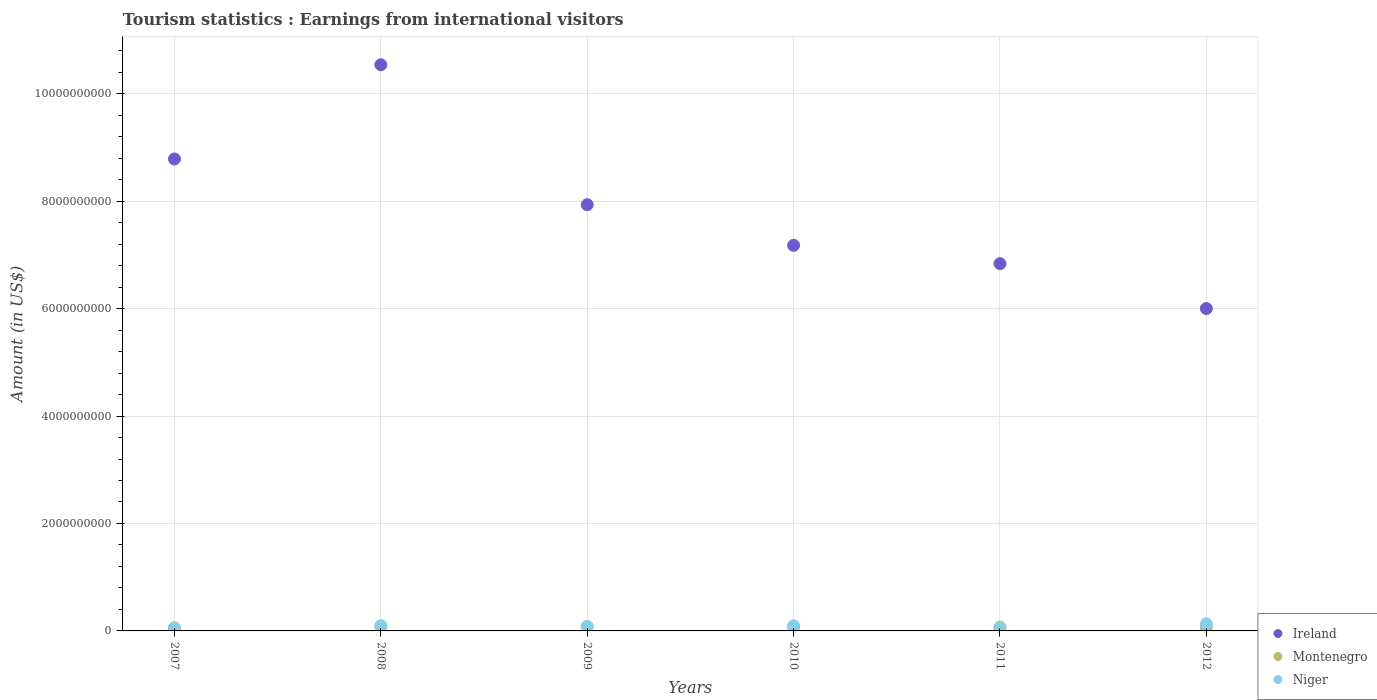What is the earnings from international visitors in Montenegro in 2007?
Your answer should be compact. 5.80e+07. Across all years, what is the maximum earnings from international visitors in Niger?
Provide a succinct answer. 1.32e+08. Across all years, what is the minimum earnings from international visitors in Ireland?
Your answer should be very brief. 6.00e+09. What is the total earnings from international visitors in Niger in the graph?
Provide a short and direct response. 5.14e+08. What is the difference between the earnings from international visitors in Niger in 2007 and that in 2009?
Your answer should be very brief. -3.60e+07. What is the difference between the earnings from international visitors in Niger in 2011 and the earnings from international visitors in Ireland in 2010?
Ensure brevity in your answer.  -7.12e+09. What is the average earnings from international visitors in Niger per year?
Keep it short and to the point. 8.57e+07. In the year 2007, what is the difference between the earnings from international visitors in Ireland and earnings from international visitors in Niger?
Provide a short and direct response. 8.74e+09. What is the ratio of the earnings from international visitors in Ireland in 2008 to that in 2010?
Give a very brief answer. 1.47. Is the earnings from international visitors in Ireland in 2008 less than that in 2011?
Provide a short and direct response. No. Is the difference between the earnings from international visitors in Ireland in 2007 and 2008 greater than the difference between the earnings from international visitors in Niger in 2007 and 2008?
Your answer should be very brief. No. What is the difference between the highest and the second highest earnings from international visitors in Ireland?
Make the answer very short. 1.75e+09. What is the difference between the highest and the lowest earnings from international visitors in Ireland?
Provide a succinct answer. 4.54e+09. Is the sum of the earnings from international visitors in Niger in 2010 and 2012 greater than the maximum earnings from international visitors in Montenegro across all years?
Provide a succinct answer. Yes. How many dotlines are there?
Provide a succinct answer. 3. How many years are there in the graph?
Your answer should be very brief. 6. What is the difference between two consecutive major ticks on the Y-axis?
Your response must be concise. 2.00e+09. Are the values on the major ticks of Y-axis written in scientific E-notation?
Ensure brevity in your answer.  No. How are the legend labels stacked?
Keep it short and to the point. Vertical. What is the title of the graph?
Keep it short and to the point. Tourism statistics : Earnings from international visitors. What is the label or title of the X-axis?
Your response must be concise. Years. What is the label or title of the Y-axis?
Your answer should be compact. Amount (in US$). What is the Amount (in US$) of Ireland in 2007?
Keep it short and to the point. 8.78e+09. What is the Amount (in US$) of Montenegro in 2007?
Your response must be concise. 5.80e+07. What is the Amount (in US$) of Niger in 2007?
Keep it short and to the point. 4.80e+07. What is the Amount (in US$) of Ireland in 2008?
Give a very brief answer. 1.05e+1. What is the Amount (in US$) of Montenegro in 2008?
Offer a terse response. 8.00e+07. What is the Amount (in US$) of Niger in 2008?
Offer a very short reply. 9.80e+07. What is the Amount (in US$) of Ireland in 2009?
Offer a very short reply. 7.93e+09. What is the Amount (in US$) of Montenegro in 2009?
Ensure brevity in your answer.  7.60e+07. What is the Amount (in US$) of Niger in 2009?
Give a very brief answer. 8.40e+07. What is the Amount (in US$) in Ireland in 2010?
Offer a terse response. 7.18e+09. What is the Amount (in US$) of Montenegro in 2010?
Provide a succinct answer. 7.20e+07. What is the Amount (in US$) of Niger in 2010?
Provide a succinct answer. 9.50e+07. What is the Amount (in US$) in Ireland in 2011?
Provide a short and direct response. 6.84e+09. What is the Amount (in US$) in Montenegro in 2011?
Make the answer very short. 7.00e+07. What is the Amount (in US$) in Niger in 2011?
Ensure brevity in your answer.  5.70e+07. What is the Amount (in US$) of Ireland in 2012?
Give a very brief answer. 6.00e+09. What is the Amount (in US$) of Montenegro in 2012?
Your answer should be compact. 6.70e+07. What is the Amount (in US$) in Niger in 2012?
Your response must be concise. 1.32e+08. Across all years, what is the maximum Amount (in US$) of Ireland?
Offer a very short reply. 1.05e+1. Across all years, what is the maximum Amount (in US$) in Montenegro?
Keep it short and to the point. 8.00e+07. Across all years, what is the maximum Amount (in US$) of Niger?
Your response must be concise. 1.32e+08. Across all years, what is the minimum Amount (in US$) of Ireland?
Your answer should be very brief. 6.00e+09. Across all years, what is the minimum Amount (in US$) in Montenegro?
Your answer should be compact. 5.80e+07. Across all years, what is the minimum Amount (in US$) in Niger?
Offer a very short reply. 4.80e+07. What is the total Amount (in US$) of Ireland in the graph?
Your answer should be very brief. 4.73e+1. What is the total Amount (in US$) in Montenegro in the graph?
Provide a short and direct response. 4.23e+08. What is the total Amount (in US$) of Niger in the graph?
Your answer should be compact. 5.14e+08. What is the difference between the Amount (in US$) in Ireland in 2007 and that in 2008?
Offer a terse response. -1.75e+09. What is the difference between the Amount (in US$) in Montenegro in 2007 and that in 2008?
Give a very brief answer. -2.20e+07. What is the difference between the Amount (in US$) of Niger in 2007 and that in 2008?
Keep it short and to the point. -5.00e+07. What is the difference between the Amount (in US$) of Ireland in 2007 and that in 2009?
Give a very brief answer. 8.51e+08. What is the difference between the Amount (in US$) in Montenegro in 2007 and that in 2009?
Offer a terse response. -1.80e+07. What is the difference between the Amount (in US$) in Niger in 2007 and that in 2009?
Keep it short and to the point. -3.60e+07. What is the difference between the Amount (in US$) of Ireland in 2007 and that in 2010?
Your answer should be compact. 1.61e+09. What is the difference between the Amount (in US$) in Montenegro in 2007 and that in 2010?
Provide a short and direct response. -1.40e+07. What is the difference between the Amount (in US$) of Niger in 2007 and that in 2010?
Make the answer very short. -4.70e+07. What is the difference between the Amount (in US$) of Ireland in 2007 and that in 2011?
Provide a succinct answer. 1.95e+09. What is the difference between the Amount (in US$) of Montenegro in 2007 and that in 2011?
Provide a short and direct response. -1.20e+07. What is the difference between the Amount (in US$) of Niger in 2007 and that in 2011?
Keep it short and to the point. -9.00e+06. What is the difference between the Amount (in US$) of Ireland in 2007 and that in 2012?
Provide a short and direct response. 2.78e+09. What is the difference between the Amount (in US$) in Montenegro in 2007 and that in 2012?
Your answer should be very brief. -9.00e+06. What is the difference between the Amount (in US$) in Niger in 2007 and that in 2012?
Make the answer very short. -8.40e+07. What is the difference between the Amount (in US$) of Ireland in 2008 and that in 2009?
Give a very brief answer. 2.60e+09. What is the difference between the Amount (in US$) of Montenegro in 2008 and that in 2009?
Your response must be concise. 4.00e+06. What is the difference between the Amount (in US$) of Niger in 2008 and that in 2009?
Keep it short and to the point. 1.40e+07. What is the difference between the Amount (in US$) of Ireland in 2008 and that in 2010?
Provide a short and direct response. 3.36e+09. What is the difference between the Amount (in US$) in Niger in 2008 and that in 2010?
Offer a very short reply. 3.00e+06. What is the difference between the Amount (in US$) in Ireland in 2008 and that in 2011?
Your answer should be compact. 3.70e+09. What is the difference between the Amount (in US$) of Niger in 2008 and that in 2011?
Your response must be concise. 4.10e+07. What is the difference between the Amount (in US$) in Ireland in 2008 and that in 2012?
Your answer should be very brief. 4.54e+09. What is the difference between the Amount (in US$) of Montenegro in 2008 and that in 2012?
Ensure brevity in your answer.  1.30e+07. What is the difference between the Amount (in US$) in Niger in 2008 and that in 2012?
Offer a very short reply. -3.40e+07. What is the difference between the Amount (in US$) of Ireland in 2009 and that in 2010?
Your answer should be compact. 7.56e+08. What is the difference between the Amount (in US$) in Niger in 2009 and that in 2010?
Provide a short and direct response. -1.10e+07. What is the difference between the Amount (in US$) in Ireland in 2009 and that in 2011?
Your answer should be compact. 1.10e+09. What is the difference between the Amount (in US$) in Niger in 2009 and that in 2011?
Provide a succinct answer. 2.70e+07. What is the difference between the Amount (in US$) in Ireland in 2009 and that in 2012?
Offer a very short reply. 1.93e+09. What is the difference between the Amount (in US$) of Montenegro in 2009 and that in 2012?
Your response must be concise. 9.00e+06. What is the difference between the Amount (in US$) in Niger in 2009 and that in 2012?
Provide a short and direct response. -4.80e+07. What is the difference between the Amount (in US$) of Ireland in 2010 and that in 2011?
Offer a very short reply. 3.41e+08. What is the difference between the Amount (in US$) in Montenegro in 2010 and that in 2011?
Your answer should be compact. 2.00e+06. What is the difference between the Amount (in US$) of Niger in 2010 and that in 2011?
Your answer should be compact. 3.80e+07. What is the difference between the Amount (in US$) of Ireland in 2010 and that in 2012?
Provide a short and direct response. 1.18e+09. What is the difference between the Amount (in US$) in Montenegro in 2010 and that in 2012?
Your answer should be compact. 5.00e+06. What is the difference between the Amount (in US$) in Niger in 2010 and that in 2012?
Your response must be concise. -3.70e+07. What is the difference between the Amount (in US$) in Ireland in 2011 and that in 2012?
Provide a short and direct response. 8.36e+08. What is the difference between the Amount (in US$) in Montenegro in 2011 and that in 2012?
Ensure brevity in your answer.  3.00e+06. What is the difference between the Amount (in US$) in Niger in 2011 and that in 2012?
Your answer should be compact. -7.50e+07. What is the difference between the Amount (in US$) in Ireland in 2007 and the Amount (in US$) in Montenegro in 2008?
Your answer should be compact. 8.70e+09. What is the difference between the Amount (in US$) in Ireland in 2007 and the Amount (in US$) in Niger in 2008?
Keep it short and to the point. 8.69e+09. What is the difference between the Amount (in US$) of Montenegro in 2007 and the Amount (in US$) of Niger in 2008?
Your answer should be compact. -4.00e+07. What is the difference between the Amount (in US$) of Ireland in 2007 and the Amount (in US$) of Montenegro in 2009?
Your response must be concise. 8.71e+09. What is the difference between the Amount (in US$) in Ireland in 2007 and the Amount (in US$) in Niger in 2009?
Your answer should be very brief. 8.70e+09. What is the difference between the Amount (in US$) of Montenegro in 2007 and the Amount (in US$) of Niger in 2009?
Make the answer very short. -2.60e+07. What is the difference between the Amount (in US$) of Ireland in 2007 and the Amount (in US$) of Montenegro in 2010?
Your answer should be compact. 8.71e+09. What is the difference between the Amount (in US$) in Ireland in 2007 and the Amount (in US$) in Niger in 2010?
Your answer should be compact. 8.69e+09. What is the difference between the Amount (in US$) of Montenegro in 2007 and the Amount (in US$) of Niger in 2010?
Offer a terse response. -3.70e+07. What is the difference between the Amount (in US$) in Ireland in 2007 and the Amount (in US$) in Montenegro in 2011?
Offer a terse response. 8.72e+09. What is the difference between the Amount (in US$) in Ireland in 2007 and the Amount (in US$) in Niger in 2011?
Provide a short and direct response. 8.73e+09. What is the difference between the Amount (in US$) in Ireland in 2007 and the Amount (in US$) in Montenegro in 2012?
Give a very brief answer. 8.72e+09. What is the difference between the Amount (in US$) in Ireland in 2007 and the Amount (in US$) in Niger in 2012?
Your answer should be compact. 8.65e+09. What is the difference between the Amount (in US$) in Montenegro in 2007 and the Amount (in US$) in Niger in 2012?
Offer a very short reply. -7.40e+07. What is the difference between the Amount (in US$) in Ireland in 2008 and the Amount (in US$) in Montenegro in 2009?
Make the answer very short. 1.05e+1. What is the difference between the Amount (in US$) in Ireland in 2008 and the Amount (in US$) in Niger in 2009?
Make the answer very short. 1.05e+1. What is the difference between the Amount (in US$) of Ireland in 2008 and the Amount (in US$) of Montenegro in 2010?
Make the answer very short. 1.05e+1. What is the difference between the Amount (in US$) of Ireland in 2008 and the Amount (in US$) of Niger in 2010?
Ensure brevity in your answer.  1.04e+1. What is the difference between the Amount (in US$) in Montenegro in 2008 and the Amount (in US$) in Niger in 2010?
Provide a short and direct response. -1.50e+07. What is the difference between the Amount (in US$) in Ireland in 2008 and the Amount (in US$) in Montenegro in 2011?
Give a very brief answer. 1.05e+1. What is the difference between the Amount (in US$) in Ireland in 2008 and the Amount (in US$) in Niger in 2011?
Keep it short and to the point. 1.05e+1. What is the difference between the Amount (in US$) of Montenegro in 2008 and the Amount (in US$) of Niger in 2011?
Your response must be concise. 2.30e+07. What is the difference between the Amount (in US$) in Ireland in 2008 and the Amount (in US$) in Montenegro in 2012?
Offer a terse response. 1.05e+1. What is the difference between the Amount (in US$) of Ireland in 2008 and the Amount (in US$) of Niger in 2012?
Your answer should be compact. 1.04e+1. What is the difference between the Amount (in US$) in Montenegro in 2008 and the Amount (in US$) in Niger in 2012?
Ensure brevity in your answer.  -5.20e+07. What is the difference between the Amount (in US$) of Ireland in 2009 and the Amount (in US$) of Montenegro in 2010?
Provide a short and direct response. 7.86e+09. What is the difference between the Amount (in US$) of Ireland in 2009 and the Amount (in US$) of Niger in 2010?
Provide a succinct answer. 7.84e+09. What is the difference between the Amount (in US$) of Montenegro in 2009 and the Amount (in US$) of Niger in 2010?
Offer a very short reply. -1.90e+07. What is the difference between the Amount (in US$) of Ireland in 2009 and the Amount (in US$) of Montenegro in 2011?
Your response must be concise. 7.86e+09. What is the difference between the Amount (in US$) in Ireland in 2009 and the Amount (in US$) in Niger in 2011?
Offer a terse response. 7.88e+09. What is the difference between the Amount (in US$) in Montenegro in 2009 and the Amount (in US$) in Niger in 2011?
Give a very brief answer. 1.90e+07. What is the difference between the Amount (in US$) of Ireland in 2009 and the Amount (in US$) of Montenegro in 2012?
Offer a very short reply. 7.87e+09. What is the difference between the Amount (in US$) of Ireland in 2009 and the Amount (in US$) of Niger in 2012?
Offer a very short reply. 7.80e+09. What is the difference between the Amount (in US$) of Montenegro in 2009 and the Amount (in US$) of Niger in 2012?
Keep it short and to the point. -5.60e+07. What is the difference between the Amount (in US$) of Ireland in 2010 and the Amount (in US$) of Montenegro in 2011?
Your answer should be compact. 7.11e+09. What is the difference between the Amount (in US$) in Ireland in 2010 and the Amount (in US$) in Niger in 2011?
Keep it short and to the point. 7.12e+09. What is the difference between the Amount (in US$) in Montenegro in 2010 and the Amount (in US$) in Niger in 2011?
Your answer should be very brief. 1.50e+07. What is the difference between the Amount (in US$) in Ireland in 2010 and the Amount (in US$) in Montenegro in 2012?
Give a very brief answer. 7.11e+09. What is the difference between the Amount (in US$) in Ireland in 2010 and the Amount (in US$) in Niger in 2012?
Keep it short and to the point. 7.05e+09. What is the difference between the Amount (in US$) in Montenegro in 2010 and the Amount (in US$) in Niger in 2012?
Your response must be concise. -6.00e+07. What is the difference between the Amount (in US$) in Ireland in 2011 and the Amount (in US$) in Montenegro in 2012?
Your answer should be compact. 6.77e+09. What is the difference between the Amount (in US$) of Ireland in 2011 and the Amount (in US$) of Niger in 2012?
Provide a succinct answer. 6.70e+09. What is the difference between the Amount (in US$) in Montenegro in 2011 and the Amount (in US$) in Niger in 2012?
Give a very brief answer. -6.20e+07. What is the average Amount (in US$) of Ireland per year?
Your answer should be very brief. 7.88e+09. What is the average Amount (in US$) of Montenegro per year?
Offer a terse response. 7.05e+07. What is the average Amount (in US$) in Niger per year?
Give a very brief answer. 8.57e+07. In the year 2007, what is the difference between the Amount (in US$) of Ireland and Amount (in US$) of Montenegro?
Offer a very short reply. 8.73e+09. In the year 2007, what is the difference between the Amount (in US$) of Ireland and Amount (in US$) of Niger?
Keep it short and to the point. 8.74e+09. In the year 2007, what is the difference between the Amount (in US$) in Montenegro and Amount (in US$) in Niger?
Make the answer very short. 1.00e+07. In the year 2008, what is the difference between the Amount (in US$) in Ireland and Amount (in US$) in Montenegro?
Your answer should be compact. 1.05e+1. In the year 2008, what is the difference between the Amount (in US$) in Ireland and Amount (in US$) in Niger?
Make the answer very short. 1.04e+1. In the year 2008, what is the difference between the Amount (in US$) of Montenegro and Amount (in US$) of Niger?
Provide a short and direct response. -1.80e+07. In the year 2009, what is the difference between the Amount (in US$) in Ireland and Amount (in US$) in Montenegro?
Ensure brevity in your answer.  7.86e+09. In the year 2009, what is the difference between the Amount (in US$) of Ireland and Amount (in US$) of Niger?
Provide a succinct answer. 7.85e+09. In the year 2009, what is the difference between the Amount (in US$) of Montenegro and Amount (in US$) of Niger?
Offer a terse response. -8.00e+06. In the year 2010, what is the difference between the Amount (in US$) of Ireland and Amount (in US$) of Montenegro?
Provide a short and direct response. 7.11e+09. In the year 2010, what is the difference between the Amount (in US$) of Ireland and Amount (in US$) of Niger?
Provide a succinct answer. 7.08e+09. In the year 2010, what is the difference between the Amount (in US$) in Montenegro and Amount (in US$) in Niger?
Provide a short and direct response. -2.30e+07. In the year 2011, what is the difference between the Amount (in US$) of Ireland and Amount (in US$) of Montenegro?
Your response must be concise. 6.77e+09. In the year 2011, what is the difference between the Amount (in US$) of Ireland and Amount (in US$) of Niger?
Provide a succinct answer. 6.78e+09. In the year 2011, what is the difference between the Amount (in US$) of Montenegro and Amount (in US$) of Niger?
Offer a very short reply. 1.30e+07. In the year 2012, what is the difference between the Amount (in US$) in Ireland and Amount (in US$) in Montenegro?
Keep it short and to the point. 5.93e+09. In the year 2012, what is the difference between the Amount (in US$) of Ireland and Amount (in US$) of Niger?
Your response must be concise. 5.87e+09. In the year 2012, what is the difference between the Amount (in US$) in Montenegro and Amount (in US$) in Niger?
Offer a very short reply. -6.50e+07. What is the ratio of the Amount (in US$) in Ireland in 2007 to that in 2008?
Your answer should be very brief. 0.83. What is the ratio of the Amount (in US$) in Montenegro in 2007 to that in 2008?
Offer a terse response. 0.72. What is the ratio of the Amount (in US$) of Niger in 2007 to that in 2008?
Your answer should be very brief. 0.49. What is the ratio of the Amount (in US$) in Ireland in 2007 to that in 2009?
Provide a short and direct response. 1.11. What is the ratio of the Amount (in US$) of Montenegro in 2007 to that in 2009?
Your answer should be very brief. 0.76. What is the ratio of the Amount (in US$) of Ireland in 2007 to that in 2010?
Your response must be concise. 1.22. What is the ratio of the Amount (in US$) in Montenegro in 2007 to that in 2010?
Give a very brief answer. 0.81. What is the ratio of the Amount (in US$) of Niger in 2007 to that in 2010?
Give a very brief answer. 0.51. What is the ratio of the Amount (in US$) of Ireland in 2007 to that in 2011?
Your answer should be compact. 1.28. What is the ratio of the Amount (in US$) of Montenegro in 2007 to that in 2011?
Your response must be concise. 0.83. What is the ratio of the Amount (in US$) of Niger in 2007 to that in 2011?
Offer a terse response. 0.84. What is the ratio of the Amount (in US$) of Ireland in 2007 to that in 2012?
Your response must be concise. 1.46. What is the ratio of the Amount (in US$) in Montenegro in 2007 to that in 2012?
Your response must be concise. 0.87. What is the ratio of the Amount (in US$) in Niger in 2007 to that in 2012?
Provide a succinct answer. 0.36. What is the ratio of the Amount (in US$) of Ireland in 2008 to that in 2009?
Provide a short and direct response. 1.33. What is the ratio of the Amount (in US$) of Montenegro in 2008 to that in 2009?
Your answer should be compact. 1.05. What is the ratio of the Amount (in US$) of Ireland in 2008 to that in 2010?
Keep it short and to the point. 1.47. What is the ratio of the Amount (in US$) in Montenegro in 2008 to that in 2010?
Your answer should be compact. 1.11. What is the ratio of the Amount (in US$) in Niger in 2008 to that in 2010?
Give a very brief answer. 1.03. What is the ratio of the Amount (in US$) of Ireland in 2008 to that in 2011?
Your answer should be compact. 1.54. What is the ratio of the Amount (in US$) of Montenegro in 2008 to that in 2011?
Provide a succinct answer. 1.14. What is the ratio of the Amount (in US$) of Niger in 2008 to that in 2011?
Offer a very short reply. 1.72. What is the ratio of the Amount (in US$) in Ireland in 2008 to that in 2012?
Your response must be concise. 1.76. What is the ratio of the Amount (in US$) of Montenegro in 2008 to that in 2012?
Ensure brevity in your answer.  1.19. What is the ratio of the Amount (in US$) in Niger in 2008 to that in 2012?
Your answer should be compact. 0.74. What is the ratio of the Amount (in US$) in Ireland in 2009 to that in 2010?
Keep it short and to the point. 1.11. What is the ratio of the Amount (in US$) of Montenegro in 2009 to that in 2010?
Ensure brevity in your answer.  1.06. What is the ratio of the Amount (in US$) in Niger in 2009 to that in 2010?
Keep it short and to the point. 0.88. What is the ratio of the Amount (in US$) in Ireland in 2009 to that in 2011?
Your answer should be compact. 1.16. What is the ratio of the Amount (in US$) in Montenegro in 2009 to that in 2011?
Provide a short and direct response. 1.09. What is the ratio of the Amount (in US$) in Niger in 2009 to that in 2011?
Your answer should be compact. 1.47. What is the ratio of the Amount (in US$) in Ireland in 2009 to that in 2012?
Your response must be concise. 1.32. What is the ratio of the Amount (in US$) in Montenegro in 2009 to that in 2012?
Provide a succinct answer. 1.13. What is the ratio of the Amount (in US$) of Niger in 2009 to that in 2012?
Your answer should be compact. 0.64. What is the ratio of the Amount (in US$) of Ireland in 2010 to that in 2011?
Provide a short and direct response. 1.05. What is the ratio of the Amount (in US$) of Montenegro in 2010 to that in 2011?
Provide a short and direct response. 1.03. What is the ratio of the Amount (in US$) of Ireland in 2010 to that in 2012?
Make the answer very short. 1.2. What is the ratio of the Amount (in US$) of Montenegro in 2010 to that in 2012?
Give a very brief answer. 1.07. What is the ratio of the Amount (in US$) of Niger in 2010 to that in 2012?
Your answer should be very brief. 0.72. What is the ratio of the Amount (in US$) of Ireland in 2011 to that in 2012?
Your answer should be compact. 1.14. What is the ratio of the Amount (in US$) in Montenegro in 2011 to that in 2012?
Make the answer very short. 1.04. What is the ratio of the Amount (in US$) of Niger in 2011 to that in 2012?
Provide a succinct answer. 0.43. What is the difference between the highest and the second highest Amount (in US$) of Ireland?
Your response must be concise. 1.75e+09. What is the difference between the highest and the second highest Amount (in US$) in Montenegro?
Offer a terse response. 4.00e+06. What is the difference between the highest and the second highest Amount (in US$) of Niger?
Make the answer very short. 3.40e+07. What is the difference between the highest and the lowest Amount (in US$) of Ireland?
Your response must be concise. 4.54e+09. What is the difference between the highest and the lowest Amount (in US$) in Montenegro?
Ensure brevity in your answer.  2.20e+07. What is the difference between the highest and the lowest Amount (in US$) in Niger?
Give a very brief answer. 8.40e+07. 